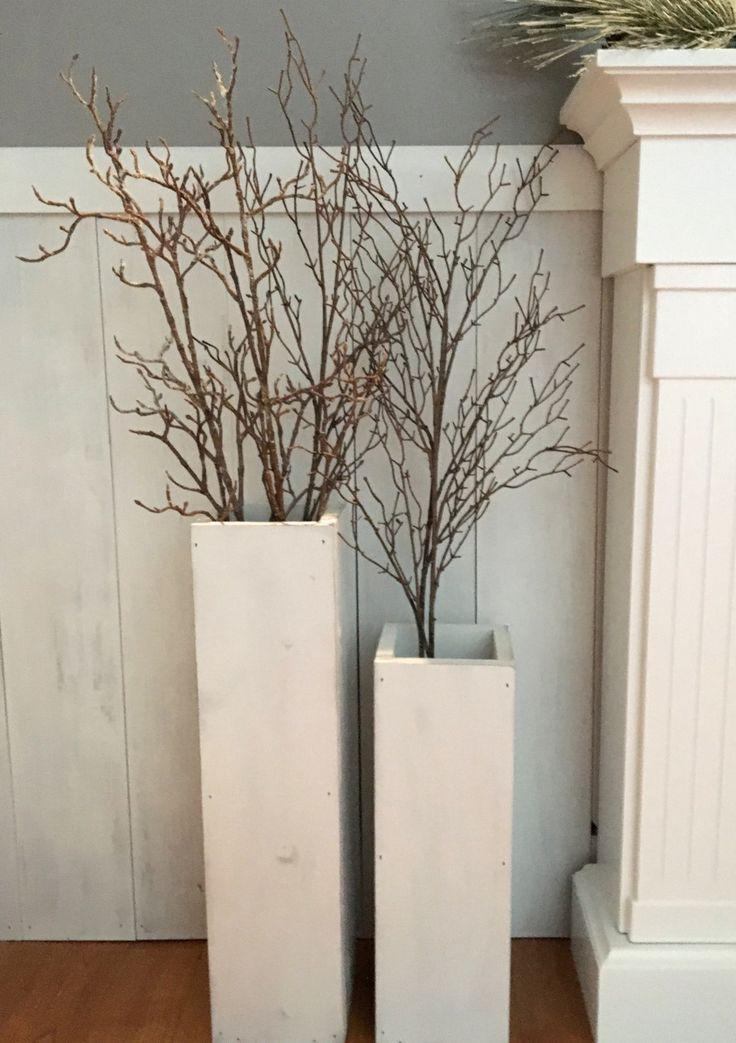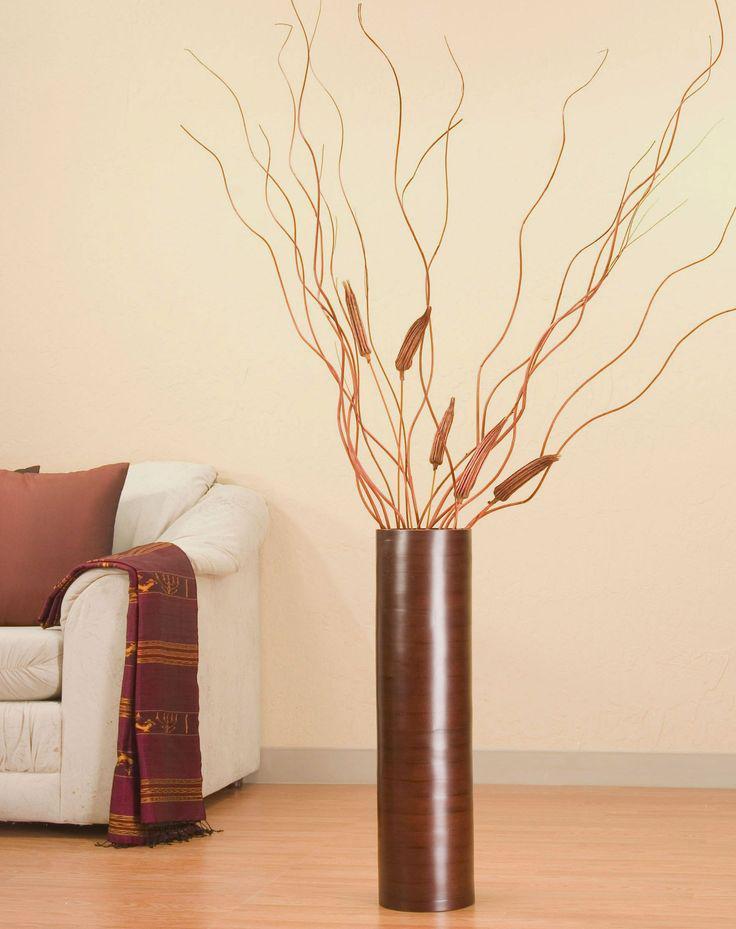The first image is the image on the left, the second image is the image on the right. Assess this claim about the two images: "there is one vase on the right image". Correct or not? Answer yes or no. Yes. 